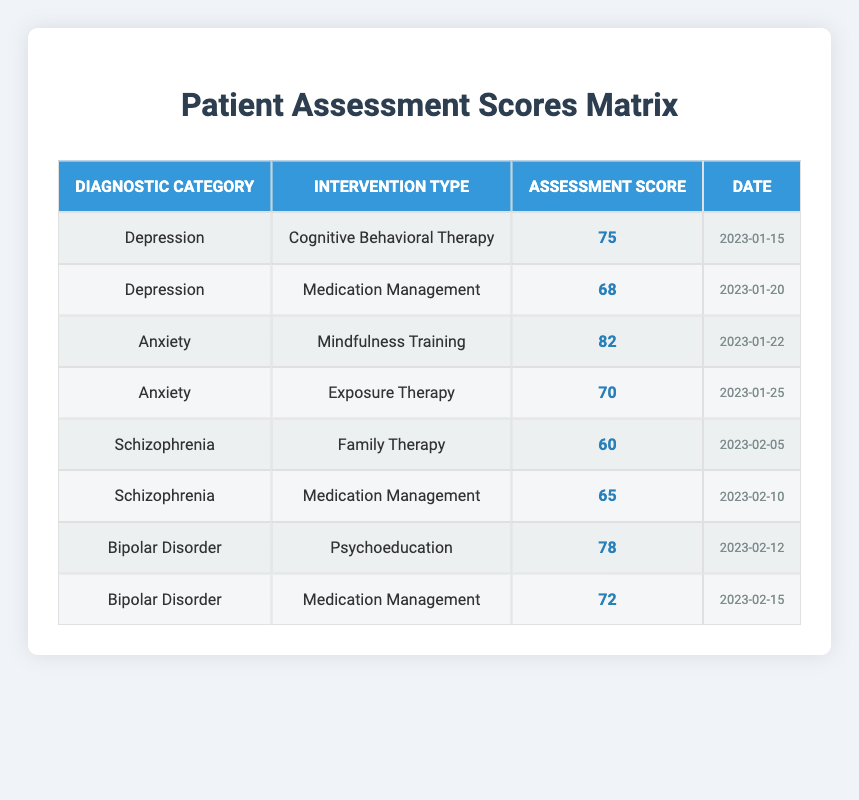What was the assessment score for Cognitive Behavioral Therapy under the Depression category? The table lists the score for Cognitive Behavioral Therapy, which falls under the Depression diagnostic category as 75. I can locate it easily in the corresponding row of the table.
Answer: 75 Which intervention type had the highest patient assessment score in the Anxiety category? Referring to the rows concerning Anxiety, I see that Mindfulness Training has an assessment score of 82, which is higher than the 70 scored for Exposure Therapy. Therefore, Mindfulness Training has the highest score in this category.
Answer: Mindfulness Training What is the patient assessment score difference between Family Therapy and Medication Management for Schizophrenia? Family Therapy scored 60, and Medication Management scored 65. To find the difference, I calculate 65 - 60, which equals 5. Thus, the difference between the two scores is 5.
Answer: 5 Are there any scores of 80 or higher in the table? When I examine the table, only the Mindfulness Training intervention under Anxiety shows a score of 82, which is indeed 80 or higher. Therefore, the answer is yes.
Answer: Yes What is the average patient assessment score for Bipolar Disorder interventions? There are two scores for Bipolar Disorder: 78 for Psychoeducation and 72 for Medication Management. The sum is 78 + 72 = 150, and the average is 150 divided by 2, which equals 75.
Answer: 75 Which diagnostic category had the lowest overall assessment score? By looking through the assessment scores for each category, I find Depression scores of 75 and 68, Anxiety scores of 82 and 70, Schizophrenia scores of 60 and 65, and Bipolar Disorder scores of 78 and 72. The lowest overall assessment score belongs to Schizophrenia where the lowest score is 60. Hence, this category has the lowest overall score.
Answer: Schizophrenia Did any of the interventions for Depression receive a score below 70? The table shows scores of 75 for Cognitive Behavioral Therapy and 68 for Medication Management under Depression. Since 68 is below 70, the answer to whether any intervention under Depression received below this score is yes.
Answer: Yes What was the date of the highest assessment score recorded in the table? After reviewing the scores, the highest score is 82 from Mindfulness Training for Anxiety, which was recorded on 2023-01-22. Therefore, this is the date associated with the highest score.
Answer: 2023-01-22 What is the total number of interventions listed for the Schizophrenia diagnostic category? Looking at the table, there are two interventions listed under Schizophrenia: Family Therapy and Medication Management. Hence, the total number of interventions for this category is 2.
Answer: 2 